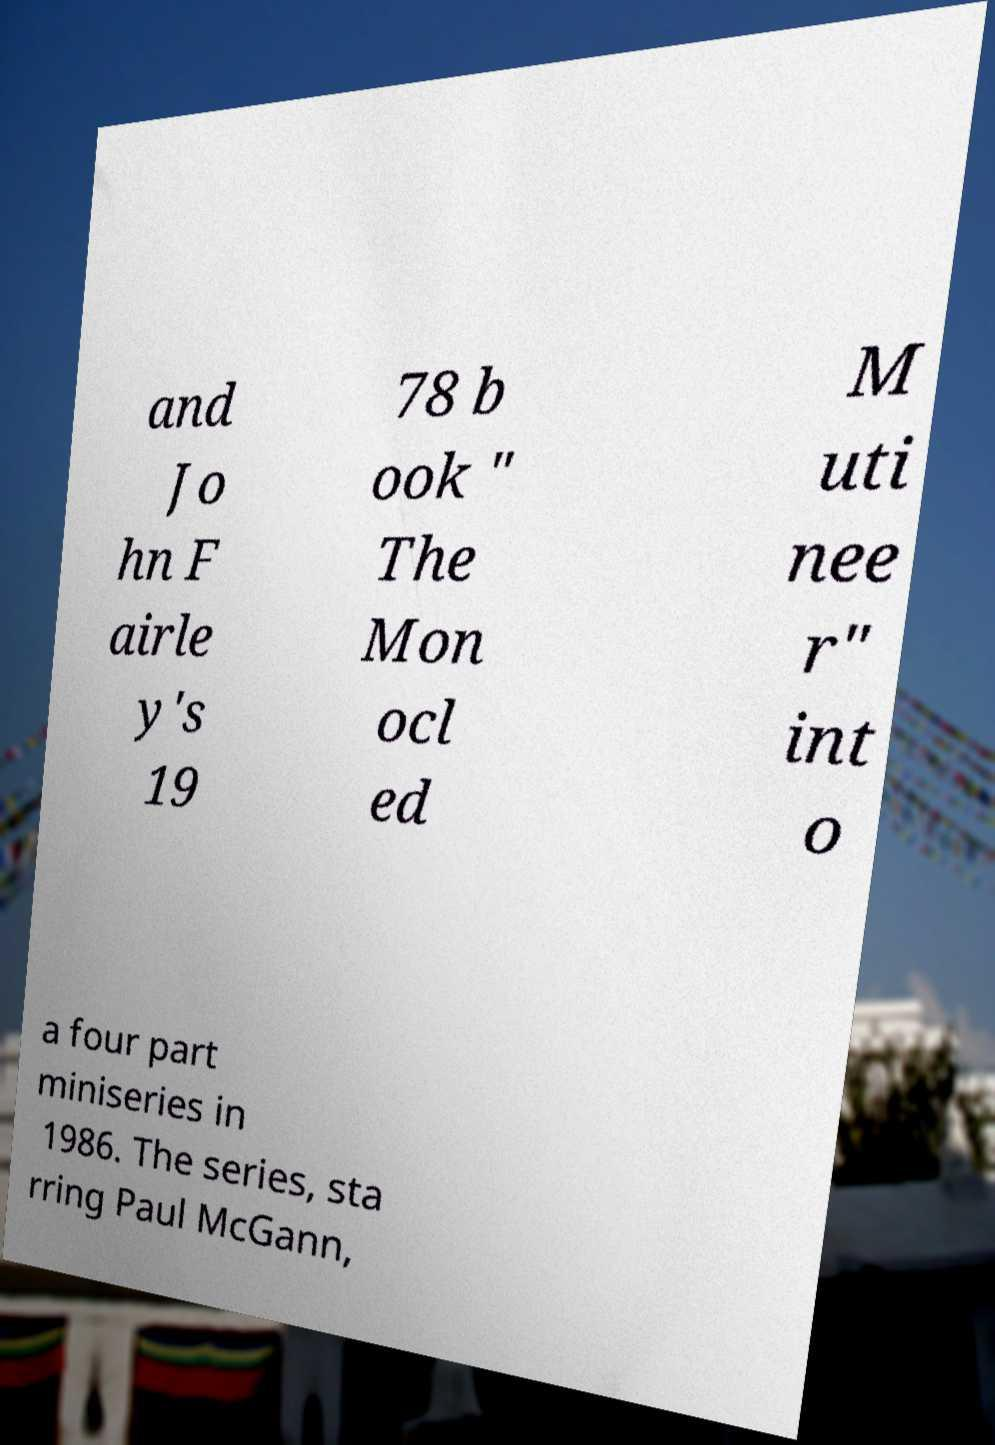Can you read and provide the text displayed in the image?This photo seems to have some interesting text. Can you extract and type it out for me? and Jo hn F airle y's 19 78 b ook " The Mon ocl ed M uti nee r" int o a four part miniseries in 1986. The series, sta rring Paul McGann, 